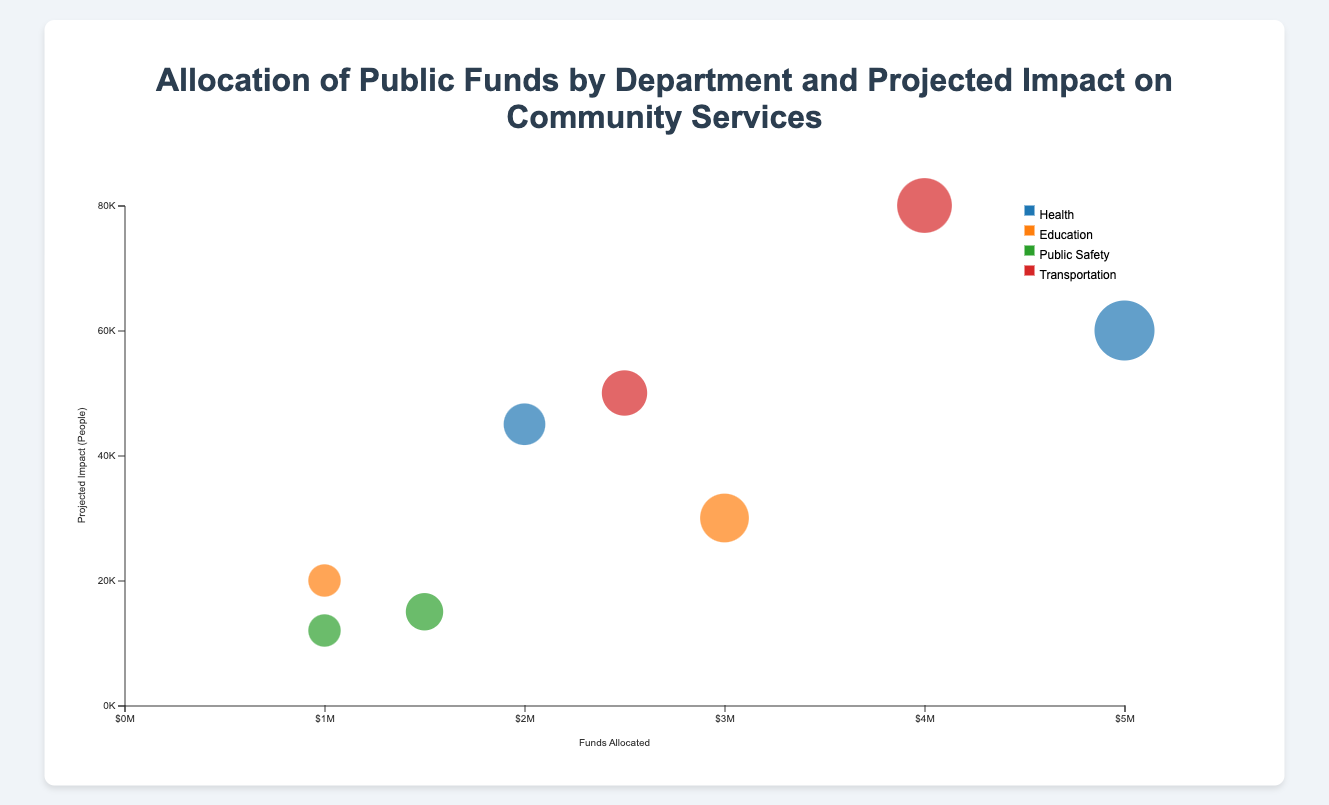What's the title of the chart? The title of the chart is displayed at the top and reads "Allocation of Public Funds by Department and Projected Impact on Community Services".
Answer: Allocation of Public Funds by Department and Projected Impact on Community Services What is represented by the size of the bubbles in the chart? The size of the bubbles in the chart represents the amount of funds allocated to the projects. Larger bubbles indicate higher funds allocated, while smaller bubbles indicate lower funds allocated.
Answer: Amount of funds allocated Which department has the project with the highest projected impact? To determine the department with the project that has the highest projected impact, look for the bubble that is highest on the y-axis. The highest bubble is for "Road Repairs" in the Transportation department with a projected impact of 80,000 people.
Answer: Transportation How many projects are shown in the chart for the Health department? The chart shows two bubbles for the Health department, one for the "Hospital Upgrade" project and one for the "Community Health Centers" project.
Answer: 2 Comparing "School Renovation" and "Teacher Training", which project has a higher projected impact and by how much? The projected impact of "School Renovation" is 30,000 people, and for "Teacher Training" it is 20,000 people. The difference in projected impact is 30,000 - 20,000 = 10,000 people.
Answer: School Renovation by 10,000 Which project requires the least amount of funds allocated and from which department is it? The chart shows the smallest bubbles represent projects with the least funds allocated. The smallest bubble is for "Teacher Training" with $1,000,000 in the Education department.
Answer: Teacher Training from Education If you combine the funds allocated to "Police Equipment" and "Fire Station Maintenance", what is the total amount allocated to these two projects? The funds allocated for "Police Equipment" is $1,500,000 and for "Fire Station Maintenance" is $1,000,000. Adding them gives $1,500,000 + $1,000,000 = $2,500,000.
Answer: $2,500,000 Which project in the Health department has a larger funds allocation, and how much more is allocated compared to the other project? "Hospital Upgrade" has a funds allocation of $5,000,000 and "Community Health Centers" has $2,000,000. The difference is $5,000,000 - $2,000,000 = $3,000,000.
Answer: Hospital Upgrade by $3,000,000 What is the projected impact of projects in the Public Safety department combined? The projected impact of "Police Equipment" is 15,000 people and "Fire Station Maintenance" is 12,000 people. Adding these gives 15,000 + 12,000 = 27,000 people.
Answer: 27,000 Which project in the Transportation department has a lower projected impact? Looking at the bubbles in the Transportation department, the "Public Transit Expansion" has a lower position on the y-axis compared to "Road Repairs". Therefore, "Public Transit Expansion" has a lower projected impact of 50,000 people.
Answer: Public Transit Expansion 